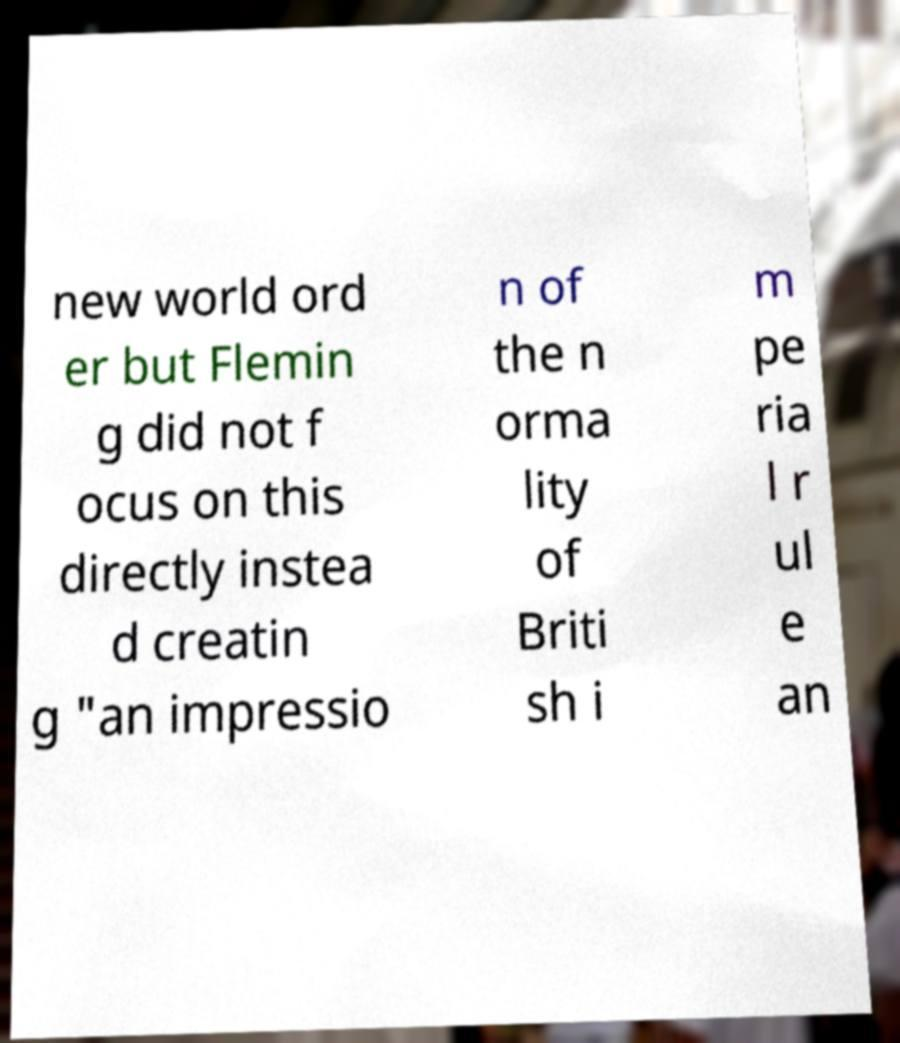Can you read and provide the text displayed in the image?This photo seems to have some interesting text. Can you extract and type it out for me? new world ord er but Flemin g did not f ocus on this directly instea d creatin g "an impressio n of the n orma lity of Briti sh i m pe ria l r ul e an 